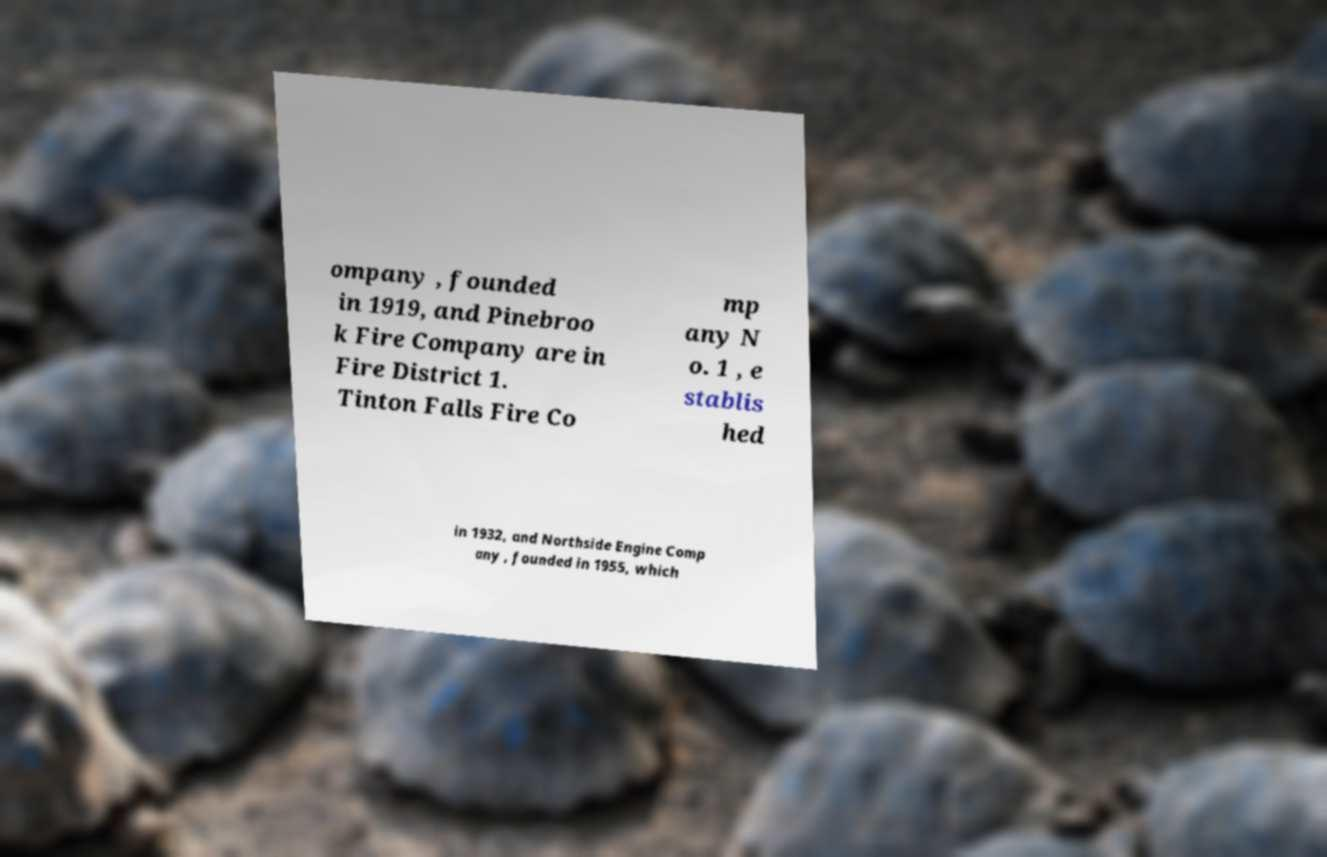What messages or text are displayed in this image? I need them in a readable, typed format. ompany , founded in 1919, and Pinebroo k Fire Company are in Fire District 1. Tinton Falls Fire Co mp any N o. 1 , e stablis hed in 1932, and Northside Engine Comp any , founded in 1955, which 